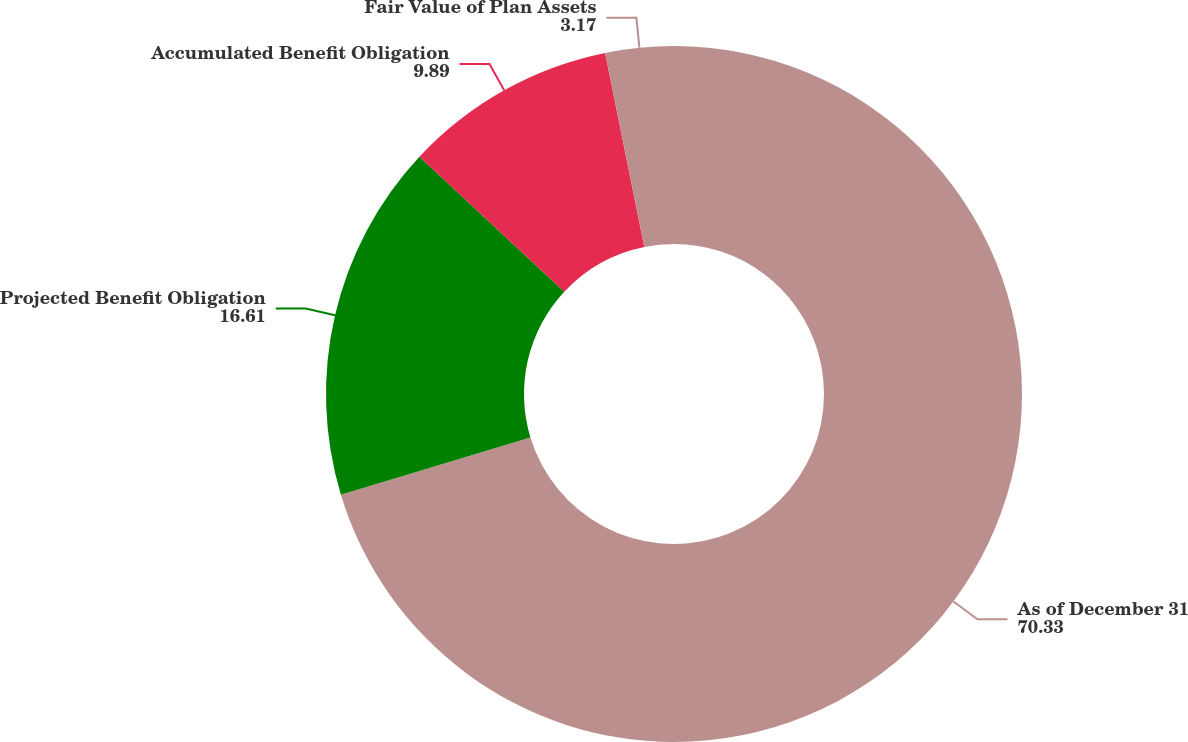<chart> <loc_0><loc_0><loc_500><loc_500><pie_chart><fcel>As of December 31<fcel>Projected Benefit Obligation<fcel>Accumulated Benefit Obligation<fcel>Fair Value of Plan Assets<nl><fcel>70.33%<fcel>16.61%<fcel>9.89%<fcel>3.17%<nl></chart> 